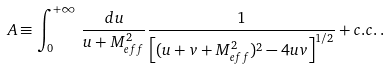Convert formula to latex. <formula><loc_0><loc_0><loc_500><loc_500>A \equiv \int _ { 0 } ^ { + \infty } \, { \frac { d u } { u + M _ { e f f } ^ { 2 } } } { \frac { 1 } { \left [ ( u + v + M _ { e f f } ^ { 2 } ) ^ { 2 } - 4 u v \right ] ^ { 1 / 2 } } } + c . c . \, .</formula> 